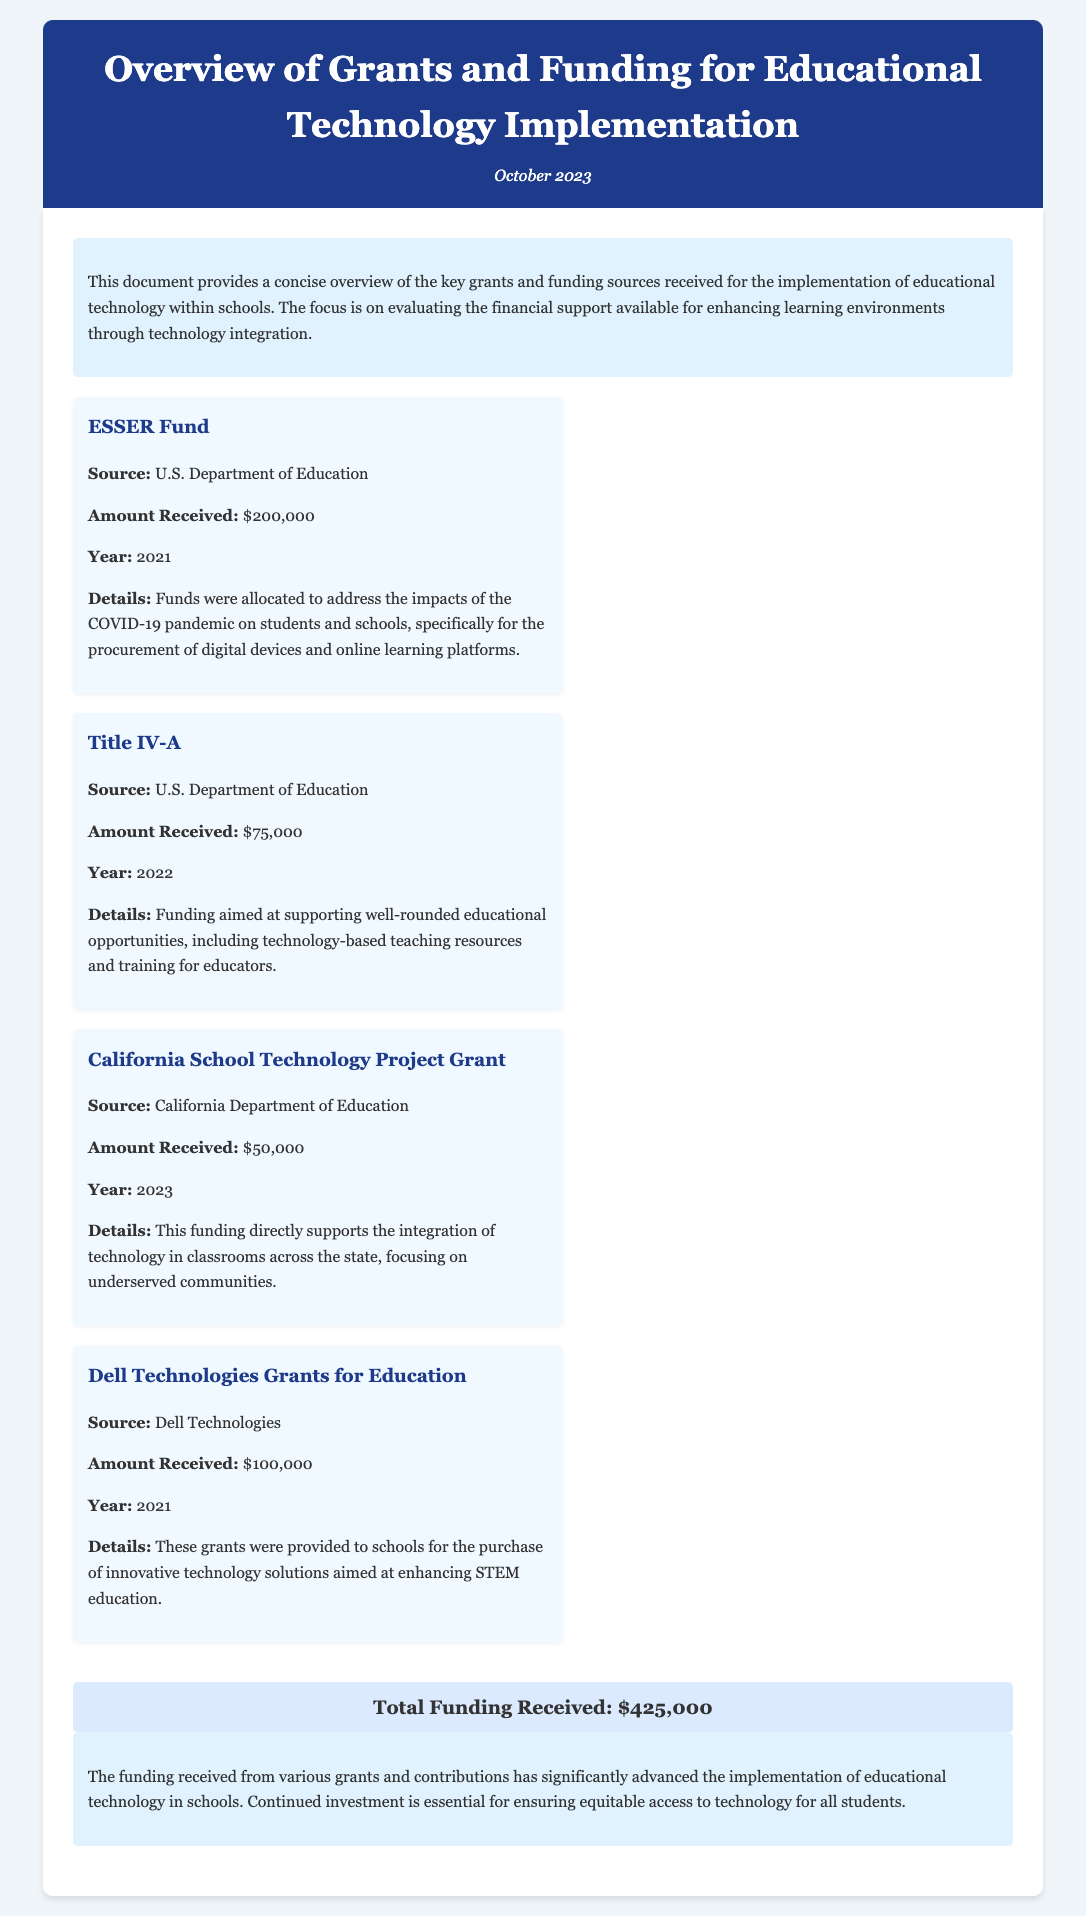What is the total funding received? The total funding is summarized at the end of the document as $425,000.
Answer: $425,000 What year was the California School Technology Project Grant received? The year the California School Technology Project Grant was awarded is specified as 2023 in the document.
Answer: 2023 What source provided the Title IV-A funding? The source of the Title IV-A funding is noted as the U.S. Department of Education in the document.
Answer: U.S. Department of Education How much funding was received from the Dell Technologies Grants for Education? The amount received from the Dell Technologies Grants for Education is mentioned in the document as $100,000.
Answer: $100,000 What was the purpose of the ESSER Fund? The ESSER Fund's purpose, as outlined in the details section, was to address the impacts of the COVID-19 pandemic on students and schools.
Answer: Address COVID-19 impacts Which grant specifically focuses on underserved communities? The California School Technology Project Grant is highlighted in the document for its focus on underserved communities.
Answer: California School Technology Project Grant How much funding did the U.S. Department of Education allocate through the ESSER Fund? The amount allocated through the ESSER Fund is explicitly mentioned as $200,000.
Answer: $200,000 What is the overall theme of the introduction? The introduction summarizes the document's focus on evaluating financial support for educational technology implementation in schools.
Answer: Evaluating financial support What is the main conclusion of the report? The conclusion emphasizes the need for continued investment in educational technology for equitable access among students.
Answer: Continued investment is essential 